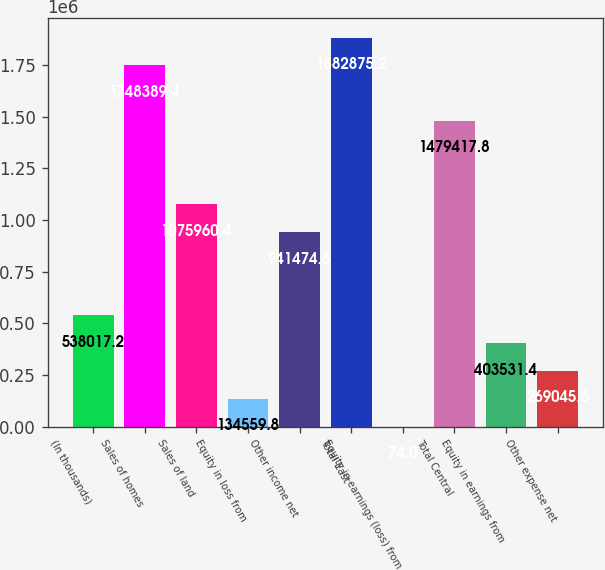Convert chart to OTSL. <chart><loc_0><loc_0><loc_500><loc_500><bar_chart><fcel>(In thousands)<fcel>Sales of homes<fcel>Sales of land<fcel>Equity in loss from<fcel>Other income net<fcel>Total East<fcel>Equity in earnings (loss) from<fcel>Total Central<fcel>Equity in earnings from<fcel>Other expense net<nl><fcel>538017<fcel>1.74839e+06<fcel>1.07596e+06<fcel>134560<fcel>941475<fcel>1.88288e+06<fcel>74<fcel>1.47942e+06<fcel>403531<fcel>269046<nl></chart> 